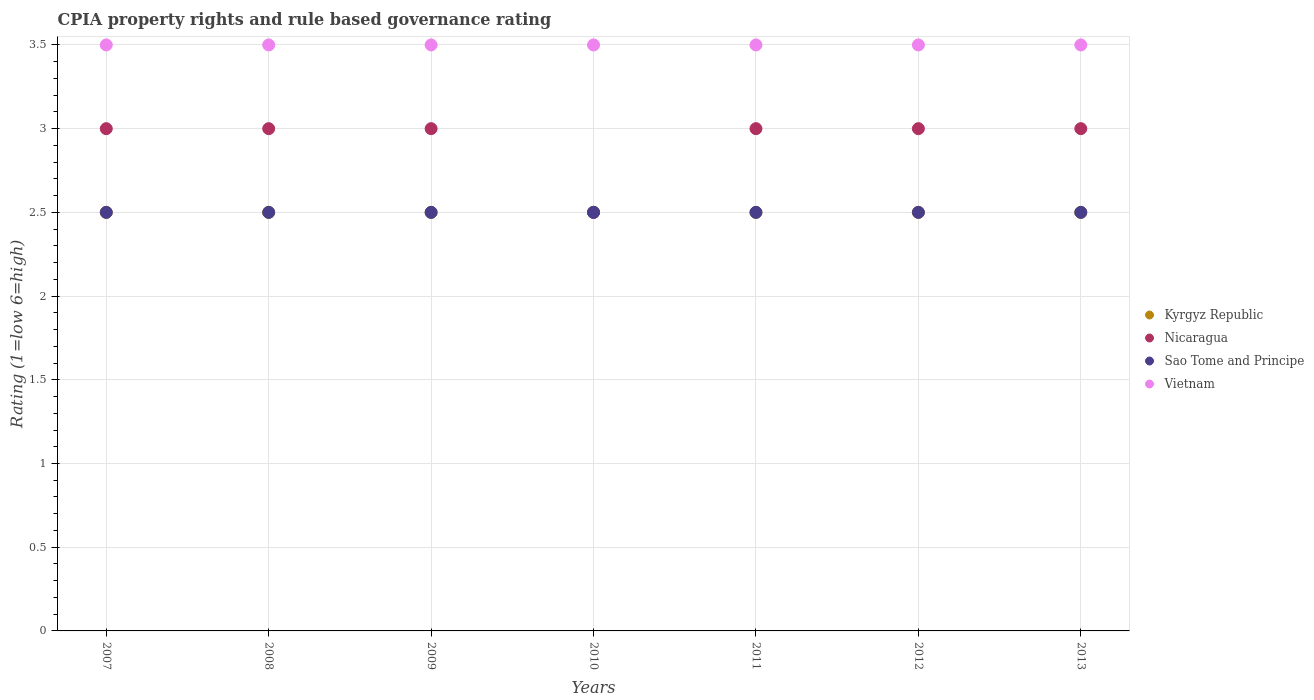What is the CPIA rating in Sao Tome and Principe in 2009?
Provide a short and direct response. 2.5. Across all years, what is the maximum CPIA rating in Vietnam?
Keep it short and to the point. 3.5. Across all years, what is the minimum CPIA rating in Sao Tome and Principe?
Make the answer very short. 2.5. In which year was the CPIA rating in Kyrgyz Republic minimum?
Your response must be concise. 2007. What is the total CPIA rating in Kyrgyz Republic in the graph?
Give a very brief answer. 17.5. What is the difference between the CPIA rating in Sao Tome and Principe in 2008 and that in 2012?
Provide a succinct answer. 0. What is the average CPIA rating in Kyrgyz Republic per year?
Your answer should be compact. 2.5. In how many years, is the CPIA rating in Nicaragua greater than 1.5?
Your answer should be very brief. 7. Is the CPIA rating in Sao Tome and Principe in 2009 less than that in 2011?
Ensure brevity in your answer.  No. Is the difference between the CPIA rating in Nicaragua in 2007 and 2008 greater than the difference between the CPIA rating in Vietnam in 2007 and 2008?
Your answer should be compact. No. What is the difference between the highest and the second highest CPIA rating in Nicaragua?
Offer a terse response. 0. Is it the case that in every year, the sum of the CPIA rating in Sao Tome and Principe and CPIA rating in Vietnam  is greater than the CPIA rating in Nicaragua?
Offer a very short reply. Yes. Is the CPIA rating in Vietnam strictly greater than the CPIA rating in Kyrgyz Republic over the years?
Make the answer very short. Yes. Is the CPIA rating in Kyrgyz Republic strictly less than the CPIA rating in Vietnam over the years?
Provide a succinct answer. Yes. How many dotlines are there?
Provide a short and direct response. 4. How many years are there in the graph?
Provide a short and direct response. 7. Are the values on the major ticks of Y-axis written in scientific E-notation?
Your answer should be compact. No. Does the graph contain any zero values?
Keep it short and to the point. No. What is the title of the graph?
Give a very brief answer. CPIA property rights and rule based governance rating. Does "Croatia" appear as one of the legend labels in the graph?
Provide a succinct answer. No. What is the label or title of the Y-axis?
Provide a short and direct response. Rating (1=low 6=high). What is the Rating (1=low 6=high) in Nicaragua in 2007?
Offer a terse response. 3. What is the Rating (1=low 6=high) of Sao Tome and Principe in 2007?
Offer a terse response. 2.5. What is the Rating (1=low 6=high) in Kyrgyz Republic in 2008?
Offer a very short reply. 2.5. What is the Rating (1=low 6=high) of Nicaragua in 2008?
Give a very brief answer. 3. What is the Rating (1=low 6=high) of Nicaragua in 2009?
Your answer should be compact. 3. What is the Rating (1=low 6=high) in Vietnam in 2009?
Keep it short and to the point. 3.5. What is the Rating (1=low 6=high) in Kyrgyz Republic in 2010?
Your answer should be very brief. 2.5. What is the Rating (1=low 6=high) of Sao Tome and Principe in 2010?
Keep it short and to the point. 2.5. What is the Rating (1=low 6=high) of Vietnam in 2011?
Your response must be concise. 3.5. What is the Rating (1=low 6=high) in Kyrgyz Republic in 2012?
Make the answer very short. 2.5. What is the Rating (1=low 6=high) of Nicaragua in 2012?
Ensure brevity in your answer.  3. What is the Rating (1=low 6=high) in Sao Tome and Principe in 2012?
Your answer should be very brief. 2.5. What is the Rating (1=low 6=high) in Nicaragua in 2013?
Provide a succinct answer. 3. Across all years, what is the maximum Rating (1=low 6=high) of Nicaragua?
Your response must be concise. 3. Across all years, what is the maximum Rating (1=low 6=high) in Sao Tome and Principe?
Offer a very short reply. 2.5. Across all years, what is the minimum Rating (1=low 6=high) in Kyrgyz Republic?
Make the answer very short. 2.5. Across all years, what is the minimum Rating (1=low 6=high) of Sao Tome and Principe?
Provide a short and direct response. 2.5. What is the total Rating (1=low 6=high) of Sao Tome and Principe in the graph?
Your answer should be very brief. 17.5. What is the total Rating (1=low 6=high) of Vietnam in the graph?
Offer a very short reply. 24.5. What is the difference between the Rating (1=low 6=high) in Nicaragua in 2007 and that in 2008?
Offer a terse response. 0. What is the difference between the Rating (1=low 6=high) in Sao Tome and Principe in 2007 and that in 2008?
Your response must be concise. 0. What is the difference between the Rating (1=low 6=high) of Kyrgyz Republic in 2007 and that in 2009?
Offer a terse response. 0. What is the difference between the Rating (1=low 6=high) of Kyrgyz Republic in 2007 and that in 2010?
Keep it short and to the point. 0. What is the difference between the Rating (1=low 6=high) in Nicaragua in 2007 and that in 2010?
Keep it short and to the point. 0.5. What is the difference between the Rating (1=low 6=high) of Vietnam in 2007 and that in 2010?
Your answer should be very brief. 0. What is the difference between the Rating (1=low 6=high) in Kyrgyz Republic in 2007 and that in 2012?
Make the answer very short. 0. What is the difference between the Rating (1=low 6=high) of Kyrgyz Republic in 2007 and that in 2013?
Provide a short and direct response. 0. What is the difference between the Rating (1=low 6=high) of Nicaragua in 2007 and that in 2013?
Keep it short and to the point. 0. What is the difference between the Rating (1=low 6=high) in Kyrgyz Republic in 2008 and that in 2009?
Keep it short and to the point. 0. What is the difference between the Rating (1=low 6=high) in Nicaragua in 2008 and that in 2009?
Your response must be concise. 0. What is the difference between the Rating (1=low 6=high) in Sao Tome and Principe in 2008 and that in 2009?
Provide a short and direct response. 0. What is the difference between the Rating (1=low 6=high) of Vietnam in 2008 and that in 2009?
Your answer should be very brief. 0. What is the difference between the Rating (1=low 6=high) in Nicaragua in 2008 and that in 2010?
Your answer should be very brief. 0.5. What is the difference between the Rating (1=low 6=high) in Nicaragua in 2008 and that in 2011?
Your response must be concise. 0. What is the difference between the Rating (1=low 6=high) of Vietnam in 2008 and that in 2011?
Your response must be concise. 0. What is the difference between the Rating (1=low 6=high) of Nicaragua in 2008 and that in 2012?
Your response must be concise. 0. What is the difference between the Rating (1=low 6=high) of Sao Tome and Principe in 2008 and that in 2012?
Your response must be concise. 0. What is the difference between the Rating (1=low 6=high) of Nicaragua in 2008 and that in 2013?
Ensure brevity in your answer.  0. What is the difference between the Rating (1=low 6=high) in Sao Tome and Principe in 2008 and that in 2013?
Keep it short and to the point. 0. What is the difference between the Rating (1=low 6=high) of Vietnam in 2008 and that in 2013?
Your answer should be very brief. 0. What is the difference between the Rating (1=low 6=high) in Kyrgyz Republic in 2009 and that in 2010?
Ensure brevity in your answer.  0. What is the difference between the Rating (1=low 6=high) of Kyrgyz Republic in 2009 and that in 2012?
Ensure brevity in your answer.  0. What is the difference between the Rating (1=low 6=high) of Sao Tome and Principe in 2009 and that in 2012?
Provide a succinct answer. 0. What is the difference between the Rating (1=low 6=high) in Vietnam in 2009 and that in 2012?
Ensure brevity in your answer.  0. What is the difference between the Rating (1=low 6=high) in Vietnam in 2009 and that in 2013?
Ensure brevity in your answer.  0. What is the difference between the Rating (1=low 6=high) in Kyrgyz Republic in 2010 and that in 2011?
Keep it short and to the point. 0. What is the difference between the Rating (1=low 6=high) of Sao Tome and Principe in 2010 and that in 2011?
Keep it short and to the point. 0. What is the difference between the Rating (1=low 6=high) in Kyrgyz Republic in 2010 and that in 2012?
Offer a very short reply. 0. What is the difference between the Rating (1=low 6=high) in Nicaragua in 2010 and that in 2012?
Ensure brevity in your answer.  -0.5. What is the difference between the Rating (1=low 6=high) of Kyrgyz Republic in 2010 and that in 2013?
Keep it short and to the point. 0. What is the difference between the Rating (1=low 6=high) of Sao Tome and Principe in 2010 and that in 2013?
Provide a short and direct response. 0. What is the difference between the Rating (1=low 6=high) in Vietnam in 2010 and that in 2013?
Your answer should be compact. 0. What is the difference between the Rating (1=low 6=high) of Kyrgyz Republic in 2011 and that in 2012?
Provide a succinct answer. 0. What is the difference between the Rating (1=low 6=high) in Sao Tome and Principe in 2011 and that in 2012?
Give a very brief answer. 0. What is the difference between the Rating (1=low 6=high) in Vietnam in 2011 and that in 2012?
Provide a succinct answer. 0. What is the difference between the Rating (1=low 6=high) in Sao Tome and Principe in 2011 and that in 2013?
Your answer should be very brief. 0. What is the difference between the Rating (1=low 6=high) of Vietnam in 2011 and that in 2013?
Your answer should be very brief. 0. What is the difference between the Rating (1=low 6=high) of Nicaragua in 2012 and that in 2013?
Keep it short and to the point. 0. What is the difference between the Rating (1=low 6=high) in Sao Tome and Principe in 2012 and that in 2013?
Your answer should be very brief. 0. What is the difference between the Rating (1=low 6=high) of Vietnam in 2012 and that in 2013?
Your answer should be compact. 0. What is the difference between the Rating (1=low 6=high) of Sao Tome and Principe in 2007 and the Rating (1=low 6=high) of Vietnam in 2008?
Provide a short and direct response. -1. What is the difference between the Rating (1=low 6=high) of Kyrgyz Republic in 2007 and the Rating (1=low 6=high) of Sao Tome and Principe in 2009?
Make the answer very short. 0. What is the difference between the Rating (1=low 6=high) in Kyrgyz Republic in 2007 and the Rating (1=low 6=high) in Vietnam in 2009?
Provide a succinct answer. -1. What is the difference between the Rating (1=low 6=high) of Nicaragua in 2007 and the Rating (1=low 6=high) of Sao Tome and Principe in 2009?
Provide a succinct answer. 0.5. What is the difference between the Rating (1=low 6=high) of Nicaragua in 2007 and the Rating (1=low 6=high) of Vietnam in 2009?
Your answer should be compact. -0.5. What is the difference between the Rating (1=low 6=high) of Sao Tome and Principe in 2007 and the Rating (1=low 6=high) of Vietnam in 2009?
Your answer should be compact. -1. What is the difference between the Rating (1=low 6=high) of Kyrgyz Republic in 2007 and the Rating (1=low 6=high) of Nicaragua in 2010?
Provide a succinct answer. 0. What is the difference between the Rating (1=low 6=high) of Kyrgyz Republic in 2007 and the Rating (1=low 6=high) of Vietnam in 2010?
Make the answer very short. -1. What is the difference between the Rating (1=low 6=high) of Nicaragua in 2007 and the Rating (1=low 6=high) of Sao Tome and Principe in 2010?
Keep it short and to the point. 0.5. What is the difference between the Rating (1=low 6=high) of Kyrgyz Republic in 2007 and the Rating (1=low 6=high) of Vietnam in 2011?
Provide a short and direct response. -1. What is the difference between the Rating (1=low 6=high) in Nicaragua in 2007 and the Rating (1=low 6=high) in Sao Tome and Principe in 2012?
Keep it short and to the point. 0.5. What is the difference between the Rating (1=low 6=high) of Nicaragua in 2007 and the Rating (1=low 6=high) of Vietnam in 2012?
Offer a very short reply. -0.5. What is the difference between the Rating (1=low 6=high) of Kyrgyz Republic in 2007 and the Rating (1=low 6=high) of Sao Tome and Principe in 2013?
Give a very brief answer. 0. What is the difference between the Rating (1=low 6=high) of Kyrgyz Republic in 2007 and the Rating (1=low 6=high) of Vietnam in 2013?
Ensure brevity in your answer.  -1. What is the difference between the Rating (1=low 6=high) in Nicaragua in 2007 and the Rating (1=low 6=high) in Sao Tome and Principe in 2013?
Your response must be concise. 0.5. What is the difference between the Rating (1=low 6=high) of Sao Tome and Principe in 2007 and the Rating (1=low 6=high) of Vietnam in 2013?
Provide a short and direct response. -1. What is the difference between the Rating (1=low 6=high) in Nicaragua in 2008 and the Rating (1=low 6=high) in Sao Tome and Principe in 2009?
Your answer should be very brief. 0.5. What is the difference between the Rating (1=low 6=high) of Nicaragua in 2008 and the Rating (1=low 6=high) of Vietnam in 2009?
Your answer should be very brief. -0.5. What is the difference between the Rating (1=low 6=high) of Kyrgyz Republic in 2008 and the Rating (1=low 6=high) of Sao Tome and Principe in 2010?
Your answer should be very brief. 0. What is the difference between the Rating (1=low 6=high) in Nicaragua in 2008 and the Rating (1=low 6=high) in Sao Tome and Principe in 2010?
Give a very brief answer. 0.5. What is the difference between the Rating (1=low 6=high) in Kyrgyz Republic in 2008 and the Rating (1=low 6=high) in Vietnam in 2011?
Provide a succinct answer. -1. What is the difference between the Rating (1=low 6=high) of Kyrgyz Republic in 2008 and the Rating (1=low 6=high) of Sao Tome and Principe in 2012?
Give a very brief answer. 0. What is the difference between the Rating (1=low 6=high) of Nicaragua in 2008 and the Rating (1=low 6=high) of Sao Tome and Principe in 2012?
Your answer should be compact. 0.5. What is the difference between the Rating (1=low 6=high) of Kyrgyz Republic in 2008 and the Rating (1=low 6=high) of Nicaragua in 2013?
Your answer should be very brief. -0.5. What is the difference between the Rating (1=low 6=high) in Kyrgyz Republic in 2008 and the Rating (1=low 6=high) in Vietnam in 2013?
Offer a very short reply. -1. What is the difference between the Rating (1=low 6=high) in Nicaragua in 2008 and the Rating (1=low 6=high) in Vietnam in 2013?
Offer a terse response. -0.5. What is the difference between the Rating (1=low 6=high) of Kyrgyz Republic in 2009 and the Rating (1=low 6=high) of Sao Tome and Principe in 2010?
Give a very brief answer. 0. What is the difference between the Rating (1=low 6=high) in Nicaragua in 2009 and the Rating (1=low 6=high) in Sao Tome and Principe in 2010?
Give a very brief answer. 0.5. What is the difference between the Rating (1=low 6=high) of Nicaragua in 2009 and the Rating (1=low 6=high) of Vietnam in 2010?
Your answer should be very brief. -0.5. What is the difference between the Rating (1=low 6=high) in Nicaragua in 2009 and the Rating (1=low 6=high) in Vietnam in 2011?
Make the answer very short. -0.5. What is the difference between the Rating (1=low 6=high) of Sao Tome and Principe in 2009 and the Rating (1=low 6=high) of Vietnam in 2011?
Ensure brevity in your answer.  -1. What is the difference between the Rating (1=low 6=high) of Kyrgyz Republic in 2009 and the Rating (1=low 6=high) of Sao Tome and Principe in 2012?
Your answer should be compact. 0. What is the difference between the Rating (1=low 6=high) in Nicaragua in 2009 and the Rating (1=low 6=high) in Sao Tome and Principe in 2012?
Offer a very short reply. 0.5. What is the difference between the Rating (1=low 6=high) of Nicaragua in 2009 and the Rating (1=low 6=high) of Vietnam in 2012?
Provide a succinct answer. -0.5. What is the difference between the Rating (1=low 6=high) in Nicaragua in 2009 and the Rating (1=low 6=high) in Sao Tome and Principe in 2013?
Provide a succinct answer. 0.5. What is the difference between the Rating (1=low 6=high) of Sao Tome and Principe in 2009 and the Rating (1=low 6=high) of Vietnam in 2013?
Offer a terse response. -1. What is the difference between the Rating (1=low 6=high) in Nicaragua in 2010 and the Rating (1=low 6=high) in Sao Tome and Principe in 2011?
Your response must be concise. 0. What is the difference between the Rating (1=low 6=high) of Nicaragua in 2010 and the Rating (1=low 6=high) of Sao Tome and Principe in 2012?
Provide a short and direct response. 0. What is the difference between the Rating (1=low 6=high) of Kyrgyz Republic in 2010 and the Rating (1=low 6=high) of Nicaragua in 2013?
Offer a very short reply. -0.5. What is the difference between the Rating (1=low 6=high) of Kyrgyz Republic in 2010 and the Rating (1=low 6=high) of Sao Tome and Principe in 2013?
Your answer should be compact. 0. What is the difference between the Rating (1=low 6=high) in Kyrgyz Republic in 2010 and the Rating (1=low 6=high) in Vietnam in 2013?
Provide a succinct answer. -1. What is the difference between the Rating (1=low 6=high) in Nicaragua in 2010 and the Rating (1=low 6=high) in Sao Tome and Principe in 2013?
Provide a succinct answer. 0. What is the difference between the Rating (1=low 6=high) of Nicaragua in 2010 and the Rating (1=low 6=high) of Vietnam in 2013?
Make the answer very short. -1. What is the difference between the Rating (1=low 6=high) in Sao Tome and Principe in 2010 and the Rating (1=low 6=high) in Vietnam in 2013?
Offer a very short reply. -1. What is the difference between the Rating (1=low 6=high) of Kyrgyz Republic in 2011 and the Rating (1=low 6=high) of Vietnam in 2012?
Offer a very short reply. -1. What is the difference between the Rating (1=low 6=high) in Nicaragua in 2011 and the Rating (1=low 6=high) in Vietnam in 2012?
Your response must be concise. -0.5. What is the difference between the Rating (1=low 6=high) in Kyrgyz Republic in 2011 and the Rating (1=low 6=high) in Sao Tome and Principe in 2013?
Provide a short and direct response. 0. What is the difference between the Rating (1=low 6=high) of Nicaragua in 2011 and the Rating (1=low 6=high) of Sao Tome and Principe in 2013?
Offer a very short reply. 0.5. What is the difference between the Rating (1=low 6=high) of Kyrgyz Republic in 2012 and the Rating (1=low 6=high) of Sao Tome and Principe in 2013?
Your response must be concise. 0. What is the difference between the Rating (1=low 6=high) in Kyrgyz Republic in 2012 and the Rating (1=low 6=high) in Vietnam in 2013?
Provide a short and direct response. -1. What is the difference between the Rating (1=low 6=high) of Nicaragua in 2012 and the Rating (1=low 6=high) of Sao Tome and Principe in 2013?
Make the answer very short. 0.5. What is the difference between the Rating (1=low 6=high) of Nicaragua in 2012 and the Rating (1=low 6=high) of Vietnam in 2013?
Provide a succinct answer. -0.5. What is the average Rating (1=low 6=high) in Nicaragua per year?
Make the answer very short. 2.93. What is the average Rating (1=low 6=high) in Sao Tome and Principe per year?
Provide a short and direct response. 2.5. What is the average Rating (1=low 6=high) in Vietnam per year?
Your response must be concise. 3.5. In the year 2007, what is the difference between the Rating (1=low 6=high) in Kyrgyz Republic and Rating (1=low 6=high) in Sao Tome and Principe?
Provide a short and direct response. 0. In the year 2007, what is the difference between the Rating (1=low 6=high) in Kyrgyz Republic and Rating (1=low 6=high) in Vietnam?
Give a very brief answer. -1. In the year 2008, what is the difference between the Rating (1=low 6=high) of Kyrgyz Republic and Rating (1=low 6=high) of Nicaragua?
Keep it short and to the point. -0.5. In the year 2008, what is the difference between the Rating (1=low 6=high) of Kyrgyz Republic and Rating (1=low 6=high) of Sao Tome and Principe?
Provide a short and direct response. 0. In the year 2008, what is the difference between the Rating (1=low 6=high) in Nicaragua and Rating (1=low 6=high) in Sao Tome and Principe?
Offer a terse response. 0.5. In the year 2008, what is the difference between the Rating (1=low 6=high) of Nicaragua and Rating (1=low 6=high) of Vietnam?
Make the answer very short. -0.5. In the year 2008, what is the difference between the Rating (1=low 6=high) in Sao Tome and Principe and Rating (1=low 6=high) in Vietnam?
Keep it short and to the point. -1. In the year 2009, what is the difference between the Rating (1=low 6=high) of Kyrgyz Republic and Rating (1=low 6=high) of Nicaragua?
Give a very brief answer. -0.5. In the year 2009, what is the difference between the Rating (1=low 6=high) of Kyrgyz Republic and Rating (1=low 6=high) of Sao Tome and Principe?
Provide a succinct answer. 0. In the year 2009, what is the difference between the Rating (1=low 6=high) in Nicaragua and Rating (1=low 6=high) in Sao Tome and Principe?
Make the answer very short. 0.5. In the year 2009, what is the difference between the Rating (1=low 6=high) in Nicaragua and Rating (1=low 6=high) in Vietnam?
Offer a very short reply. -0.5. In the year 2009, what is the difference between the Rating (1=low 6=high) of Sao Tome and Principe and Rating (1=low 6=high) of Vietnam?
Make the answer very short. -1. In the year 2010, what is the difference between the Rating (1=low 6=high) of Kyrgyz Republic and Rating (1=low 6=high) of Sao Tome and Principe?
Ensure brevity in your answer.  0. In the year 2010, what is the difference between the Rating (1=low 6=high) in Sao Tome and Principe and Rating (1=low 6=high) in Vietnam?
Keep it short and to the point. -1. In the year 2011, what is the difference between the Rating (1=low 6=high) in Kyrgyz Republic and Rating (1=low 6=high) in Nicaragua?
Provide a succinct answer. -0.5. In the year 2011, what is the difference between the Rating (1=low 6=high) of Kyrgyz Republic and Rating (1=low 6=high) of Vietnam?
Your answer should be very brief. -1. In the year 2011, what is the difference between the Rating (1=low 6=high) in Nicaragua and Rating (1=low 6=high) in Vietnam?
Ensure brevity in your answer.  -0.5. In the year 2011, what is the difference between the Rating (1=low 6=high) in Sao Tome and Principe and Rating (1=low 6=high) in Vietnam?
Offer a terse response. -1. In the year 2012, what is the difference between the Rating (1=low 6=high) of Kyrgyz Republic and Rating (1=low 6=high) of Nicaragua?
Offer a very short reply. -0.5. In the year 2012, what is the difference between the Rating (1=low 6=high) in Sao Tome and Principe and Rating (1=low 6=high) in Vietnam?
Your answer should be compact. -1. In the year 2013, what is the difference between the Rating (1=low 6=high) of Kyrgyz Republic and Rating (1=low 6=high) of Nicaragua?
Provide a short and direct response. -0.5. In the year 2013, what is the difference between the Rating (1=low 6=high) in Nicaragua and Rating (1=low 6=high) in Vietnam?
Give a very brief answer. -0.5. What is the ratio of the Rating (1=low 6=high) in Kyrgyz Republic in 2007 to that in 2008?
Offer a terse response. 1. What is the ratio of the Rating (1=low 6=high) in Kyrgyz Republic in 2007 to that in 2009?
Provide a short and direct response. 1. What is the ratio of the Rating (1=low 6=high) of Sao Tome and Principe in 2007 to that in 2009?
Give a very brief answer. 1. What is the ratio of the Rating (1=low 6=high) of Vietnam in 2007 to that in 2009?
Give a very brief answer. 1. What is the ratio of the Rating (1=low 6=high) in Nicaragua in 2007 to that in 2010?
Provide a short and direct response. 1.2. What is the ratio of the Rating (1=low 6=high) of Sao Tome and Principe in 2007 to that in 2010?
Make the answer very short. 1. What is the ratio of the Rating (1=low 6=high) of Kyrgyz Republic in 2007 to that in 2011?
Your answer should be very brief. 1. What is the ratio of the Rating (1=low 6=high) of Nicaragua in 2007 to that in 2011?
Make the answer very short. 1. What is the ratio of the Rating (1=low 6=high) in Sao Tome and Principe in 2007 to that in 2011?
Offer a very short reply. 1. What is the ratio of the Rating (1=low 6=high) in Nicaragua in 2007 to that in 2012?
Give a very brief answer. 1. What is the ratio of the Rating (1=low 6=high) of Kyrgyz Republic in 2007 to that in 2013?
Your answer should be compact. 1. What is the ratio of the Rating (1=low 6=high) in Vietnam in 2007 to that in 2013?
Keep it short and to the point. 1. What is the ratio of the Rating (1=low 6=high) in Kyrgyz Republic in 2008 to that in 2009?
Give a very brief answer. 1. What is the ratio of the Rating (1=low 6=high) in Sao Tome and Principe in 2008 to that in 2009?
Provide a succinct answer. 1. What is the ratio of the Rating (1=low 6=high) in Kyrgyz Republic in 2008 to that in 2010?
Your answer should be very brief. 1. What is the ratio of the Rating (1=low 6=high) in Sao Tome and Principe in 2008 to that in 2010?
Your answer should be compact. 1. What is the ratio of the Rating (1=low 6=high) of Kyrgyz Republic in 2008 to that in 2012?
Provide a succinct answer. 1. What is the ratio of the Rating (1=low 6=high) in Nicaragua in 2008 to that in 2013?
Give a very brief answer. 1. What is the ratio of the Rating (1=low 6=high) in Sao Tome and Principe in 2008 to that in 2013?
Offer a very short reply. 1. What is the ratio of the Rating (1=low 6=high) in Nicaragua in 2009 to that in 2011?
Provide a succinct answer. 1. What is the ratio of the Rating (1=low 6=high) in Sao Tome and Principe in 2009 to that in 2011?
Ensure brevity in your answer.  1. What is the ratio of the Rating (1=low 6=high) in Kyrgyz Republic in 2009 to that in 2012?
Give a very brief answer. 1. What is the ratio of the Rating (1=low 6=high) in Vietnam in 2009 to that in 2012?
Ensure brevity in your answer.  1. What is the ratio of the Rating (1=low 6=high) in Kyrgyz Republic in 2010 to that in 2011?
Provide a succinct answer. 1. What is the ratio of the Rating (1=low 6=high) in Nicaragua in 2010 to that in 2011?
Provide a short and direct response. 0.83. What is the ratio of the Rating (1=low 6=high) in Kyrgyz Republic in 2010 to that in 2012?
Offer a terse response. 1. What is the ratio of the Rating (1=low 6=high) of Vietnam in 2010 to that in 2013?
Make the answer very short. 1. What is the ratio of the Rating (1=low 6=high) in Kyrgyz Republic in 2011 to that in 2012?
Make the answer very short. 1. What is the ratio of the Rating (1=low 6=high) of Nicaragua in 2011 to that in 2012?
Provide a short and direct response. 1. What is the ratio of the Rating (1=low 6=high) in Sao Tome and Principe in 2011 to that in 2012?
Offer a terse response. 1. What is the ratio of the Rating (1=low 6=high) in Vietnam in 2011 to that in 2012?
Give a very brief answer. 1. What is the ratio of the Rating (1=low 6=high) in Kyrgyz Republic in 2012 to that in 2013?
Your response must be concise. 1. What is the ratio of the Rating (1=low 6=high) in Nicaragua in 2012 to that in 2013?
Provide a succinct answer. 1. What is the ratio of the Rating (1=low 6=high) of Sao Tome and Principe in 2012 to that in 2013?
Your answer should be compact. 1. What is the difference between the highest and the second highest Rating (1=low 6=high) in Kyrgyz Republic?
Provide a short and direct response. 0. What is the difference between the highest and the lowest Rating (1=low 6=high) in Kyrgyz Republic?
Ensure brevity in your answer.  0. What is the difference between the highest and the lowest Rating (1=low 6=high) in Vietnam?
Make the answer very short. 0. 